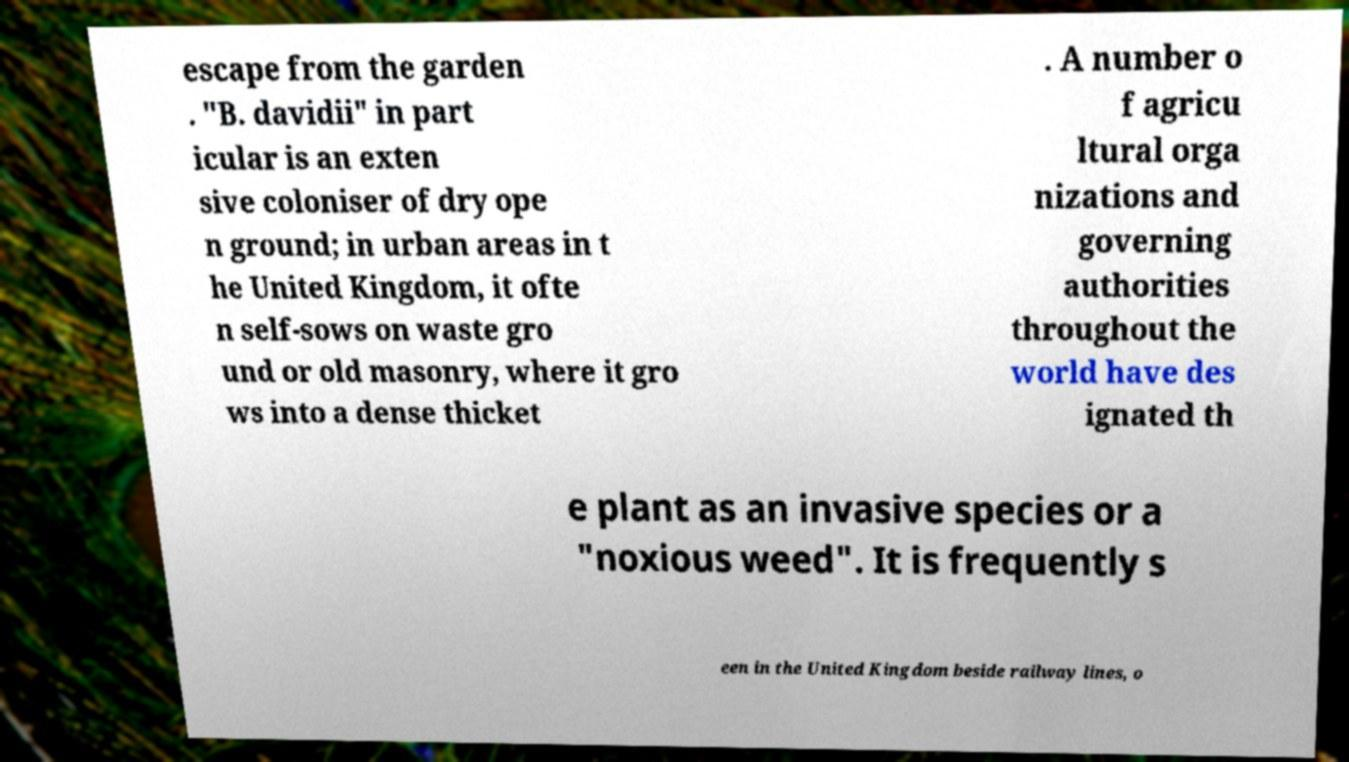Can you read and provide the text displayed in the image?This photo seems to have some interesting text. Can you extract and type it out for me? escape from the garden . "B. davidii" in part icular is an exten sive coloniser of dry ope n ground; in urban areas in t he United Kingdom, it ofte n self-sows on waste gro und or old masonry, where it gro ws into a dense thicket . A number o f agricu ltural orga nizations and governing authorities throughout the world have des ignated th e plant as an invasive species or a "noxious weed". It is frequently s een in the United Kingdom beside railway lines, o 